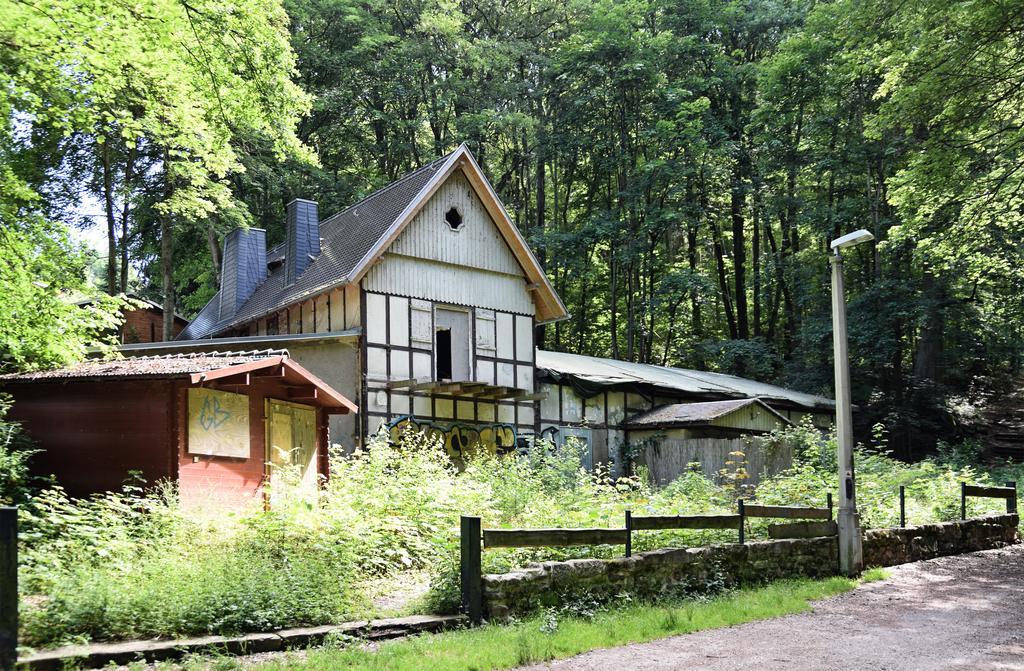Could you give a brief overview of what you see in this image? In this image I can see few houses,trees,wooden fencing and light pole. The sky is in white color. 